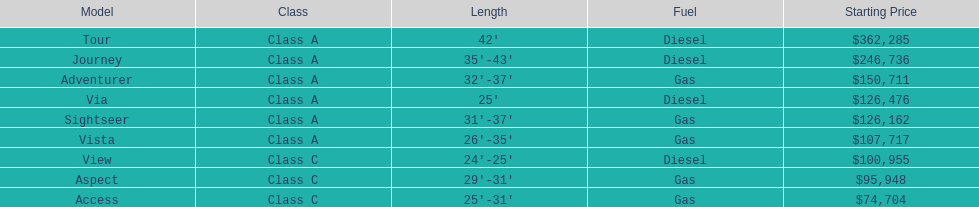What is the price of bot the via and tour models combined? $488,761. 